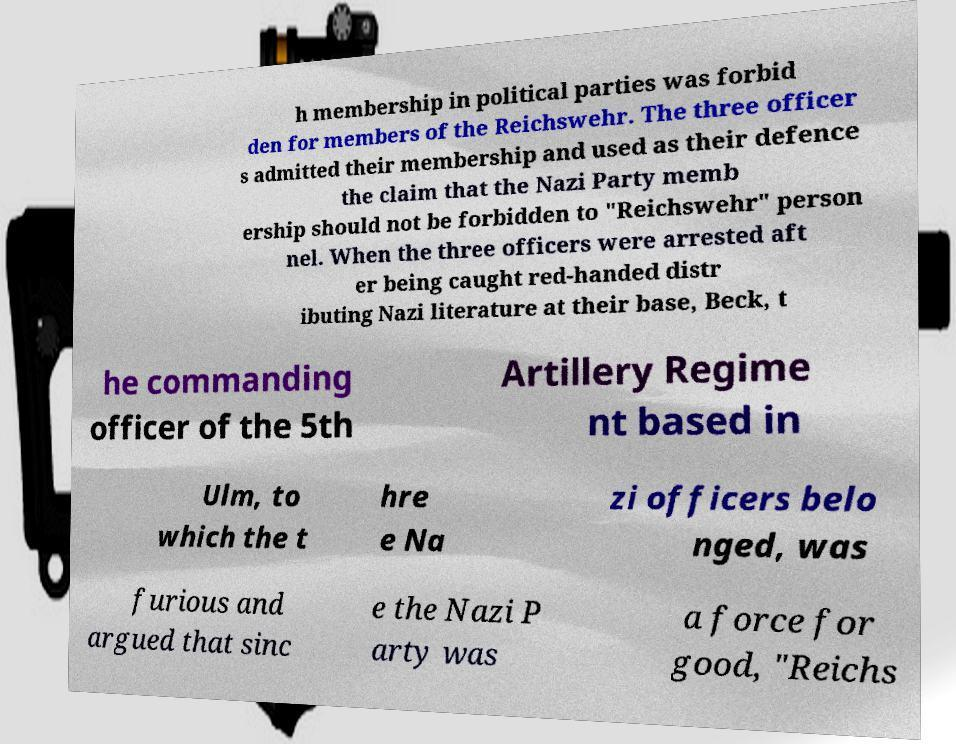What messages or text are displayed in this image? I need them in a readable, typed format. h membership in political parties was forbid den for members of the Reichswehr. The three officer s admitted their membership and used as their defence the claim that the Nazi Party memb ership should not be forbidden to "Reichswehr" person nel. When the three officers were arrested aft er being caught red-handed distr ibuting Nazi literature at their base, Beck, t he commanding officer of the 5th Artillery Regime nt based in Ulm, to which the t hre e Na zi officers belo nged, was furious and argued that sinc e the Nazi P arty was a force for good, "Reichs 